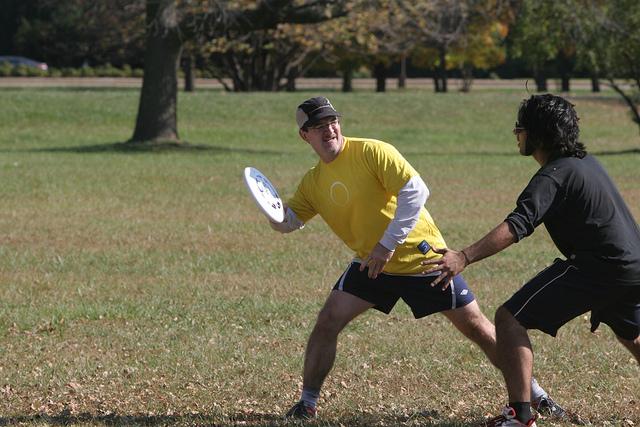Are both men wearing shorts?
Give a very brief answer. Yes. What season is this?
Concise answer only. Summer. What number is on the yellow shirt?
Short answer required. 0. Which hand will throw the Frisbee?
Give a very brief answer. Right. 